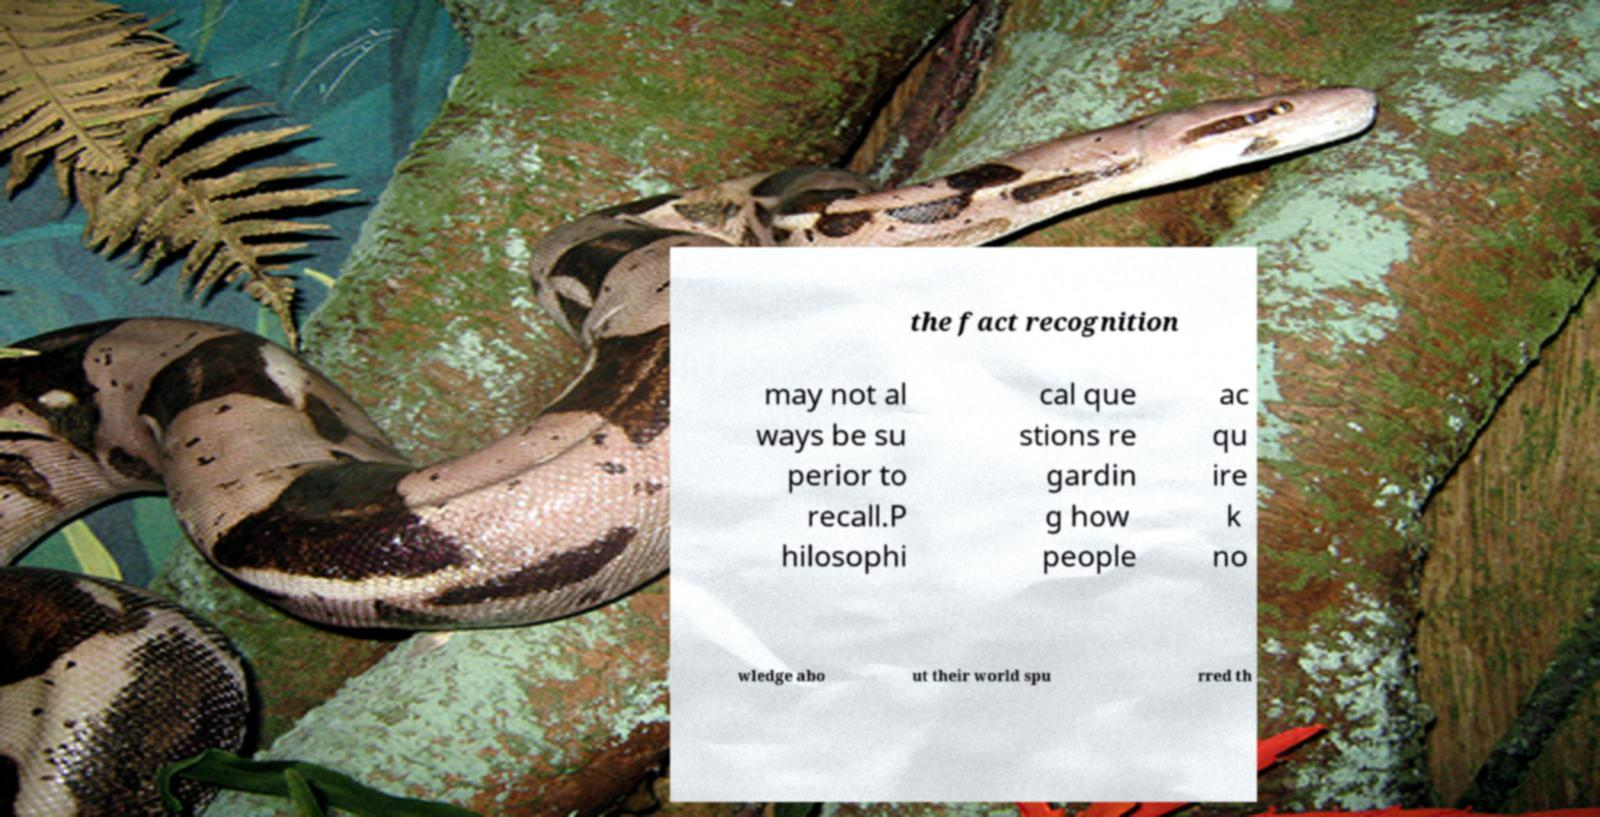Could you assist in decoding the text presented in this image and type it out clearly? the fact recognition may not al ways be su perior to recall.P hilosophi cal que stions re gardin g how people ac qu ire k no wledge abo ut their world spu rred th 